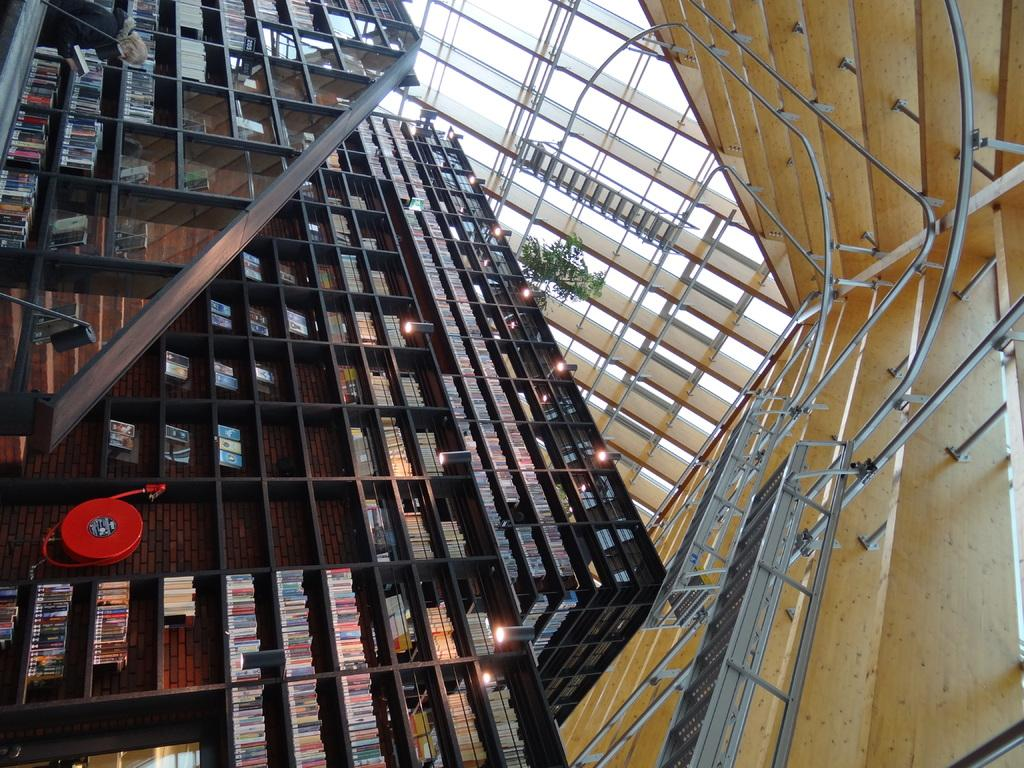What type of items can be seen in the racks in the image? There are books in racks in the image. What can be seen illuminating the area in the image? There are lights visible in the image. What is the person holding in the image? There is a person holding a book in the image. What can be seen in the background of the image? There is a plant, rods, and a roof visible in the background of the image. Can you tell me how many times the person in the image has been on a flight? There is no information about the person's flight history in the image. What type of hook is attached to the plant in the background of the image? There is no hook present in the image; it features a plant, rods, and a roof in the background. 